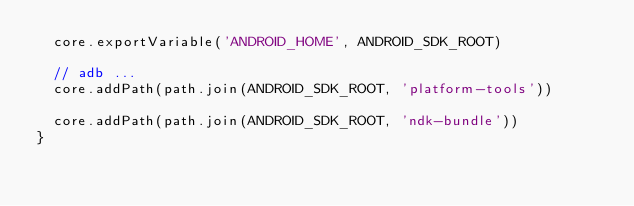Convert code to text. <code><loc_0><loc_0><loc_500><loc_500><_TypeScript_>  core.exportVariable('ANDROID_HOME', ANDROID_SDK_ROOT)

  // adb ...
  core.addPath(path.join(ANDROID_SDK_ROOT, 'platform-tools'))

  core.addPath(path.join(ANDROID_SDK_ROOT, 'ndk-bundle'))
}
</code> 